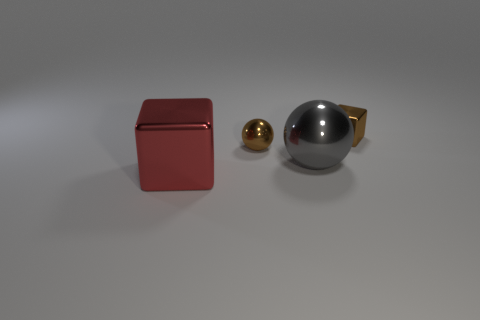Is there any other thing that is the same size as the brown shiny cube?
Give a very brief answer. Yes. Is there anything else of the same color as the big cube?
Your response must be concise. No. Do the shiny block that is right of the big metal block and the brown thing on the left side of the gray metallic sphere have the same size?
Your answer should be very brief. Yes. Are there any other things that have the same material as the small brown block?
Keep it short and to the point. Yes. What number of tiny things are shiny objects or gray metallic cylinders?
Make the answer very short. 2. What number of objects are either tiny brown metal objects in front of the tiny shiny block or gray things?
Give a very brief answer. 2. Does the tiny ball have the same color as the small metal cube?
Give a very brief answer. Yes. How many other objects are there of the same shape as the big gray object?
Your response must be concise. 1. What number of brown things are tiny shiny things or metallic objects?
Ensure brevity in your answer.  2. There is a big cube that is made of the same material as the tiny brown cube; what color is it?
Offer a terse response. Red. 